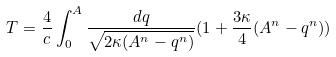Convert formula to latex. <formula><loc_0><loc_0><loc_500><loc_500>T = \frac { 4 } { c } \int _ { 0 } ^ { A } \frac { d q } { \sqrt { 2 \kappa ( A ^ { n } - q ^ { n } ) } } ( 1 + \frac { 3 \kappa } { 4 } ( A ^ { n } - q ^ { n } ) )</formula> 